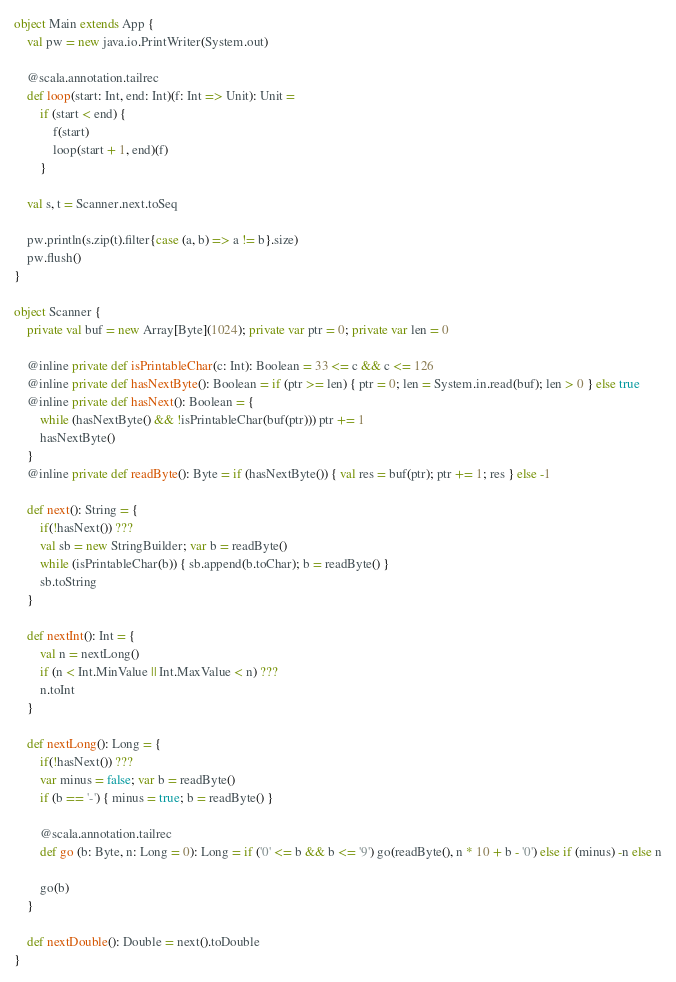Convert code to text. <code><loc_0><loc_0><loc_500><loc_500><_Scala_>object Main extends App {
	val pw = new java.io.PrintWriter(System.out)

	@scala.annotation.tailrec
	def loop(start: Int, end: Int)(f: Int => Unit): Unit =
		if (start < end) {
			f(start)
			loop(start + 1, end)(f)
		}

	val s, t = Scanner.next.toSeq

	pw.println(s.zip(t).filter{case (a, b) => a != b}.size)
	pw.flush()
}

object Scanner {
	private val buf = new Array[Byte](1024); private var ptr = 0; private var len = 0

	@inline private def isPrintableChar(c: Int): Boolean = 33 <= c && c <= 126
	@inline private def hasNextByte(): Boolean = if (ptr >= len) { ptr = 0; len = System.in.read(buf); len > 0 } else true
	@inline private def hasNext(): Boolean = {
		while (hasNextByte() && !isPrintableChar(buf(ptr))) ptr += 1
		hasNextByte()
	}
	@inline private def readByte(): Byte = if (hasNextByte()) { val res = buf(ptr); ptr += 1; res } else -1

	def next(): String = {
		if(!hasNext()) ???
		val sb = new StringBuilder; var b = readByte()
		while (isPrintableChar(b)) { sb.append(b.toChar); b = readByte() }
		sb.toString
	}

	def nextInt(): Int = {
		val n = nextLong()
		if (n < Int.MinValue || Int.MaxValue < n) ???
		n.toInt
	}

	def nextLong(): Long = {
		if(!hasNext()) ???
		var minus = false; var b = readByte()
		if (b == '-') { minus = true; b = readByte() }

		@scala.annotation.tailrec
		def go (b: Byte, n: Long = 0): Long = if ('0' <= b && b <= '9') go(readByte(), n * 10 + b - '0') else if (minus) -n else n

		go(b)
	}

	def nextDouble(): Double = next().toDouble
}
</code> 